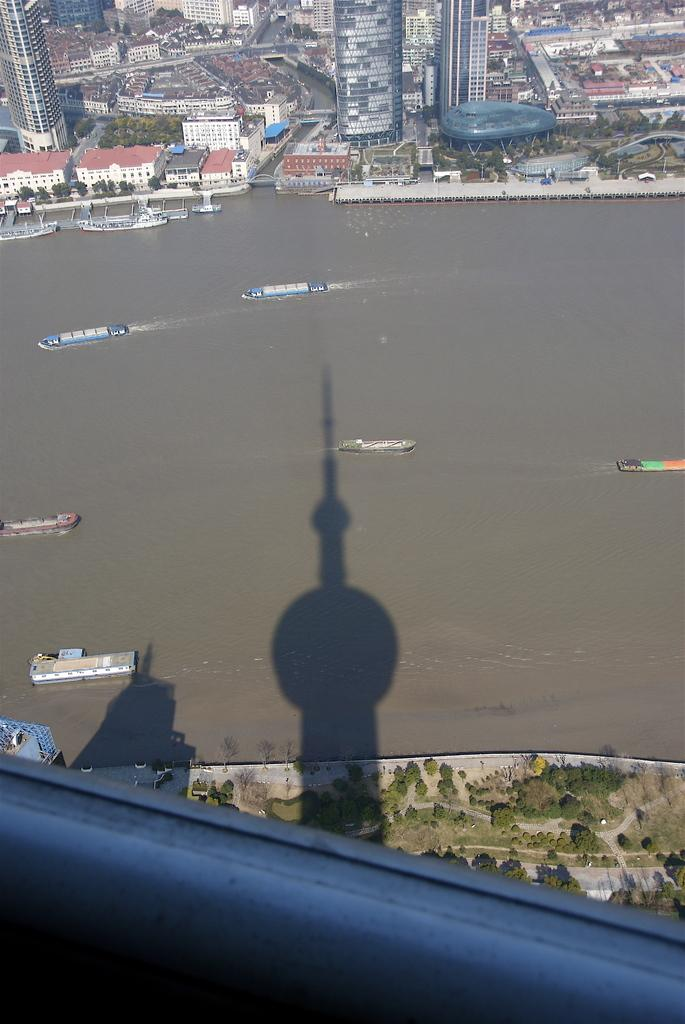What is visible in the image? Water, boats, trees, and buildings are visible in the image. What type of vehicles can be seen in the image? Boats can be seen in the image. What type of natural vegetation is present in the image? Trees are present in the image. What type of man-made structures are visible in the image? Buildings are visible in the image. Can you tell me how many cans of paint are used by the actor in the image? There is no actor or cans of paint present in the image. What type of son can be seen playing with the can in the image? There is no son or can present in the image. 